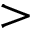<formula> <loc_0><loc_0><loc_500><loc_500>></formula> 